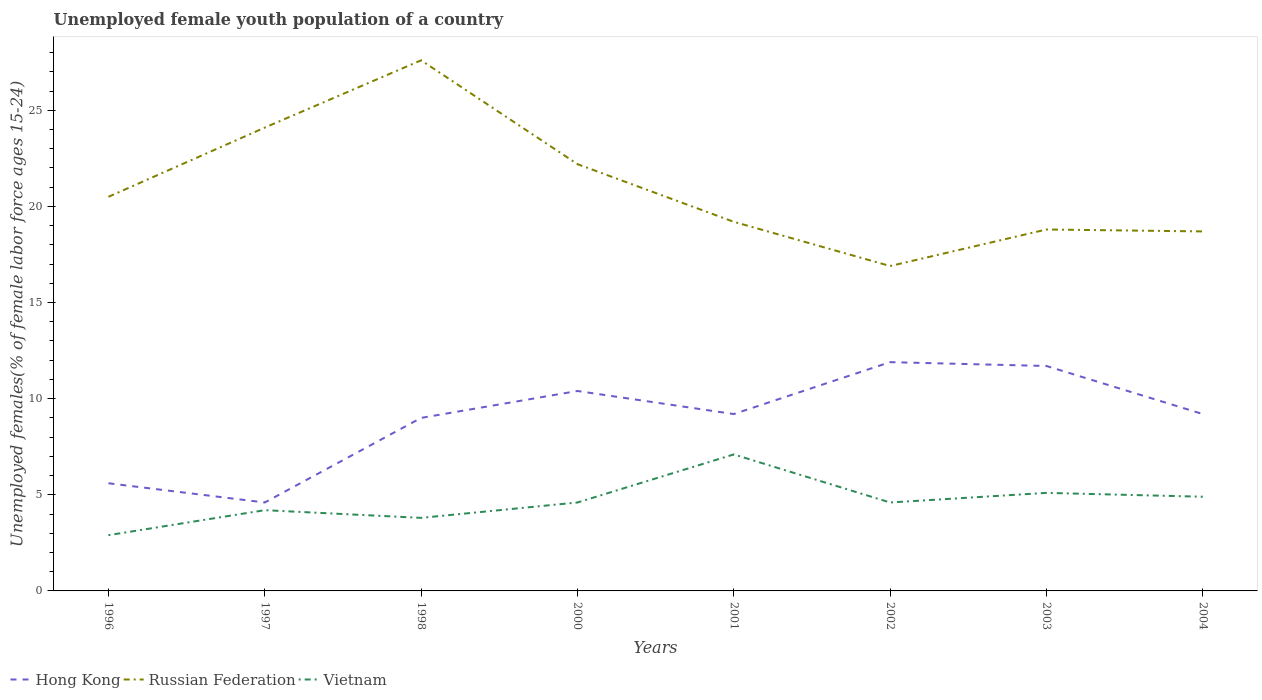How many different coloured lines are there?
Your response must be concise. 3. Across all years, what is the maximum percentage of unemployed female youth population in Vietnam?
Keep it short and to the point. 2.9. What is the total percentage of unemployed female youth population in Hong Kong in the graph?
Make the answer very short. 0. What is the difference between the highest and the second highest percentage of unemployed female youth population in Vietnam?
Provide a succinct answer. 4.2. How many lines are there?
Provide a succinct answer. 3. What is the difference between two consecutive major ticks on the Y-axis?
Offer a terse response. 5. Where does the legend appear in the graph?
Ensure brevity in your answer.  Bottom left. How many legend labels are there?
Offer a terse response. 3. How are the legend labels stacked?
Provide a short and direct response. Horizontal. What is the title of the graph?
Ensure brevity in your answer.  Unemployed female youth population of a country. What is the label or title of the Y-axis?
Offer a very short reply. Unemployed females(% of female labor force ages 15-24). What is the Unemployed females(% of female labor force ages 15-24) of Hong Kong in 1996?
Ensure brevity in your answer.  5.6. What is the Unemployed females(% of female labor force ages 15-24) in Russian Federation in 1996?
Your answer should be very brief. 20.5. What is the Unemployed females(% of female labor force ages 15-24) of Vietnam in 1996?
Offer a terse response. 2.9. What is the Unemployed females(% of female labor force ages 15-24) of Hong Kong in 1997?
Provide a short and direct response. 4.6. What is the Unemployed females(% of female labor force ages 15-24) of Russian Federation in 1997?
Your response must be concise. 24.1. What is the Unemployed females(% of female labor force ages 15-24) of Vietnam in 1997?
Make the answer very short. 4.2. What is the Unemployed females(% of female labor force ages 15-24) of Russian Federation in 1998?
Offer a very short reply. 27.6. What is the Unemployed females(% of female labor force ages 15-24) in Vietnam in 1998?
Offer a very short reply. 3.8. What is the Unemployed females(% of female labor force ages 15-24) of Hong Kong in 2000?
Keep it short and to the point. 10.4. What is the Unemployed females(% of female labor force ages 15-24) of Russian Federation in 2000?
Give a very brief answer. 22.2. What is the Unemployed females(% of female labor force ages 15-24) in Vietnam in 2000?
Ensure brevity in your answer.  4.6. What is the Unemployed females(% of female labor force ages 15-24) of Hong Kong in 2001?
Ensure brevity in your answer.  9.2. What is the Unemployed females(% of female labor force ages 15-24) of Russian Federation in 2001?
Offer a terse response. 19.2. What is the Unemployed females(% of female labor force ages 15-24) in Vietnam in 2001?
Provide a short and direct response. 7.1. What is the Unemployed females(% of female labor force ages 15-24) in Hong Kong in 2002?
Provide a short and direct response. 11.9. What is the Unemployed females(% of female labor force ages 15-24) of Russian Federation in 2002?
Offer a very short reply. 16.9. What is the Unemployed females(% of female labor force ages 15-24) in Vietnam in 2002?
Your response must be concise. 4.6. What is the Unemployed females(% of female labor force ages 15-24) in Hong Kong in 2003?
Offer a very short reply. 11.7. What is the Unemployed females(% of female labor force ages 15-24) in Russian Federation in 2003?
Offer a very short reply. 18.8. What is the Unemployed females(% of female labor force ages 15-24) in Vietnam in 2003?
Offer a terse response. 5.1. What is the Unemployed females(% of female labor force ages 15-24) of Hong Kong in 2004?
Keep it short and to the point. 9.2. What is the Unemployed females(% of female labor force ages 15-24) of Russian Federation in 2004?
Ensure brevity in your answer.  18.7. What is the Unemployed females(% of female labor force ages 15-24) in Vietnam in 2004?
Offer a terse response. 4.9. Across all years, what is the maximum Unemployed females(% of female labor force ages 15-24) of Hong Kong?
Provide a short and direct response. 11.9. Across all years, what is the maximum Unemployed females(% of female labor force ages 15-24) in Russian Federation?
Your answer should be very brief. 27.6. Across all years, what is the maximum Unemployed females(% of female labor force ages 15-24) in Vietnam?
Keep it short and to the point. 7.1. Across all years, what is the minimum Unemployed females(% of female labor force ages 15-24) of Hong Kong?
Your response must be concise. 4.6. Across all years, what is the minimum Unemployed females(% of female labor force ages 15-24) in Russian Federation?
Make the answer very short. 16.9. Across all years, what is the minimum Unemployed females(% of female labor force ages 15-24) of Vietnam?
Make the answer very short. 2.9. What is the total Unemployed females(% of female labor force ages 15-24) in Hong Kong in the graph?
Keep it short and to the point. 71.6. What is the total Unemployed females(% of female labor force ages 15-24) in Russian Federation in the graph?
Your response must be concise. 168. What is the total Unemployed females(% of female labor force ages 15-24) of Vietnam in the graph?
Ensure brevity in your answer.  37.2. What is the difference between the Unemployed females(% of female labor force ages 15-24) in Hong Kong in 1996 and that in 1997?
Provide a short and direct response. 1. What is the difference between the Unemployed females(% of female labor force ages 15-24) in Russian Federation in 1996 and that in 1997?
Give a very brief answer. -3.6. What is the difference between the Unemployed females(% of female labor force ages 15-24) in Vietnam in 1996 and that in 1997?
Make the answer very short. -1.3. What is the difference between the Unemployed females(% of female labor force ages 15-24) in Vietnam in 1996 and that in 1998?
Offer a terse response. -0.9. What is the difference between the Unemployed females(% of female labor force ages 15-24) in Russian Federation in 1996 and that in 2001?
Provide a short and direct response. 1.3. What is the difference between the Unemployed females(% of female labor force ages 15-24) in Russian Federation in 1996 and that in 2003?
Keep it short and to the point. 1.7. What is the difference between the Unemployed females(% of female labor force ages 15-24) in Vietnam in 1996 and that in 2003?
Offer a terse response. -2.2. What is the difference between the Unemployed females(% of female labor force ages 15-24) of Russian Federation in 1996 and that in 2004?
Offer a very short reply. 1.8. What is the difference between the Unemployed females(% of female labor force ages 15-24) of Vietnam in 1996 and that in 2004?
Ensure brevity in your answer.  -2. What is the difference between the Unemployed females(% of female labor force ages 15-24) in Hong Kong in 1997 and that in 1998?
Provide a succinct answer. -4.4. What is the difference between the Unemployed females(% of female labor force ages 15-24) of Russian Federation in 1997 and that in 1998?
Offer a very short reply. -3.5. What is the difference between the Unemployed females(% of female labor force ages 15-24) in Vietnam in 1997 and that in 2000?
Your answer should be very brief. -0.4. What is the difference between the Unemployed females(% of female labor force ages 15-24) in Hong Kong in 1997 and that in 2001?
Offer a very short reply. -4.6. What is the difference between the Unemployed females(% of female labor force ages 15-24) of Vietnam in 1997 and that in 2002?
Ensure brevity in your answer.  -0.4. What is the difference between the Unemployed females(% of female labor force ages 15-24) in Russian Federation in 1997 and that in 2003?
Your answer should be very brief. 5.3. What is the difference between the Unemployed females(% of female labor force ages 15-24) of Vietnam in 1997 and that in 2003?
Ensure brevity in your answer.  -0.9. What is the difference between the Unemployed females(% of female labor force ages 15-24) of Hong Kong in 1997 and that in 2004?
Give a very brief answer. -4.6. What is the difference between the Unemployed females(% of female labor force ages 15-24) in Hong Kong in 1998 and that in 2001?
Ensure brevity in your answer.  -0.2. What is the difference between the Unemployed females(% of female labor force ages 15-24) of Russian Federation in 1998 and that in 2001?
Your response must be concise. 8.4. What is the difference between the Unemployed females(% of female labor force ages 15-24) of Hong Kong in 1998 and that in 2002?
Make the answer very short. -2.9. What is the difference between the Unemployed females(% of female labor force ages 15-24) of Russian Federation in 1998 and that in 2002?
Your answer should be compact. 10.7. What is the difference between the Unemployed females(% of female labor force ages 15-24) in Hong Kong in 1998 and that in 2004?
Your answer should be very brief. -0.2. What is the difference between the Unemployed females(% of female labor force ages 15-24) of Russian Federation in 1998 and that in 2004?
Offer a very short reply. 8.9. What is the difference between the Unemployed females(% of female labor force ages 15-24) of Vietnam in 1998 and that in 2004?
Offer a very short reply. -1.1. What is the difference between the Unemployed females(% of female labor force ages 15-24) in Hong Kong in 2000 and that in 2001?
Your answer should be compact. 1.2. What is the difference between the Unemployed females(% of female labor force ages 15-24) in Russian Federation in 2000 and that in 2001?
Make the answer very short. 3. What is the difference between the Unemployed females(% of female labor force ages 15-24) in Vietnam in 2000 and that in 2001?
Offer a terse response. -2.5. What is the difference between the Unemployed females(% of female labor force ages 15-24) in Hong Kong in 2000 and that in 2002?
Keep it short and to the point. -1.5. What is the difference between the Unemployed females(% of female labor force ages 15-24) of Vietnam in 2000 and that in 2003?
Provide a short and direct response. -0.5. What is the difference between the Unemployed females(% of female labor force ages 15-24) in Russian Federation in 2000 and that in 2004?
Your answer should be very brief. 3.5. What is the difference between the Unemployed females(% of female labor force ages 15-24) of Vietnam in 2000 and that in 2004?
Your answer should be very brief. -0.3. What is the difference between the Unemployed females(% of female labor force ages 15-24) of Russian Federation in 2001 and that in 2002?
Your response must be concise. 2.3. What is the difference between the Unemployed females(% of female labor force ages 15-24) in Hong Kong in 2001 and that in 2003?
Keep it short and to the point. -2.5. What is the difference between the Unemployed females(% of female labor force ages 15-24) of Russian Federation in 2001 and that in 2003?
Provide a succinct answer. 0.4. What is the difference between the Unemployed females(% of female labor force ages 15-24) of Vietnam in 2001 and that in 2004?
Offer a terse response. 2.2. What is the difference between the Unemployed females(% of female labor force ages 15-24) in Hong Kong in 2002 and that in 2003?
Offer a very short reply. 0.2. What is the difference between the Unemployed females(% of female labor force ages 15-24) in Vietnam in 2002 and that in 2003?
Your response must be concise. -0.5. What is the difference between the Unemployed females(% of female labor force ages 15-24) in Hong Kong in 2002 and that in 2004?
Give a very brief answer. 2.7. What is the difference between the Unemployed females(% of female labor force ages 15-24) of Vietnam in 2003 and that in 2004?
Keep it short and to the point. 0.2. What is the difference between the Unemployed females(% of female labor force ages 15-24) of Hong Kong in 1996 and the Unemployed females(% of female labor force ages 15-24) of Russian Federation in 1997?
Provide a short and direct response. -18.5. What is the difference between the Unemployed females(% of female labor force ages 15-24) in Hong Kong in 1996 and the Unemployed females(% of female labor force ages 15-24) in Vietnam in 1997?
Your answer should be very brief. 1.4. What is the difference between the Unemployed females(% of female labor force ages 15-24) of Hong Kong in 1996 and the Unemployed females(% of female labor force ages 15-24) of Russian Federation in 1998?
Provide a succinct answer. -22. What is the difference between the Unemployed females(% of female labor force ages 15-24) of Hong Kong in 1996 and the Unemployed females(% of female labor force ages 15-24) of Vietnam in 1998?
Your response must be concise. 1.8. What is the difference between the Unemployed females(% of female labor force ages 15-24) in Hong Kong in 1996 and the Unemployed females(% of female labor force ages 15-24) in Russian Federation in 2000?
Provide a short and direct response. -16.6. What is the difference between the Unemployed females(% of female labor force ages 15-24) in Hong Kong in 1996 and the Unemployed females(% of female labor force ages 15-24) in Vietnam in 2000?
Your answer should be very brief. 1. What is the difference between the Unemployed females(% of female labor force ages 15-24) of Hong Kong in 1996 and the Unemployed females(% of female labor force ages 15-24) of Russian Federation in 2001?
Offer a very short reply. -13.6. What is the difference between the Unemployed females(% of female labor force ages 15-24) in Hong Kong in 1996 and the Unemployed females(% of female labor force ages 15-24) in Vietnam in 2001?
Provide a short and direct response. -1.5. What is the difference between the Unemployed females(% of female labor force ages 15-24) of Hong Kong in 1996 and the Unemployed females(% of female labor force ages 15-24) of Russian Federation in 2002?
Offer a terse response. -11.3. What is the difference between the Unemployed females(% of female labor force ages 15-24) in Hong Kong in 1996 and the Unemployed females(% of female labor force ages 15-24) in Vietnam in 2002?
Give a very brief answer. 1. What is the difference between the Unemployed females(% of female labor force ages 15-24) in Hong Kong in 1996 and the Unemployed females(% of female labor force ages 15-24) in Vietnam in 2003?
Keep it short and to the point. 0.5. What is the difference between the Unemployed females(% of female labor force ages 15-24) in Russian Federation in 1996 and the Unemployed females(% of female labor force ages 15-24) in Vietnam in 2003?
Make the answer very short. 15.4. What is the difference between the Unemployed females(% of female labor force ages 15-24) of Hong Kong in 1996 and the Unemployed females(% of female labor force ages 15-24) of Russian Federation in 2004?
Provide a succinct answer. -13.1. What is the difference between the Unemployed females(% of female labor force ages 15-24) in Russian Federation in 1996 and the Unemployed females(% of female labor force ages 15-24) in Vietnam in 2004?
Your answer should be very brief. 15.6. What is the difference between the Unemployed females(% of female labor force ages 15-24) in Russian Federation in 1997 and the Unemployed females(% of female labor force ages 15-24) in Vietnam in 1998?
Make the answer very short. 20.3. What is the difference between the Unemployed females(% of female labor force ages 15-24) in Hong Kong in 1997 and the Unemployed females(% of female labor force ages 15-24) in Russian Federation in 2000?
Make the answer very short. -17.6. What is the difference between the Unemployed females(% of female labor force ages 15-24) in Hong Kong in 1997 and the Unemployed females(% of female labor force ages 15-24) in Russian Federation in 2001?
Ensure brevity in your answer.  -14.6. What is the difference between the Unemployed females(% of female labor force ages 15-24) in Hong Kong in 1997 and the Unemployed females(% of female labor force ages 15-24) in Vietnam in 2001?
Your response must be concise. -2.5. What is the difference between the Unemployed females(% of female labor force ages 15-24) of Russian Federation in 1997 and the Unemployed females(% of female labor force ages 15-24) of Vietnam in 2001?
Offer a terse response. 17. What is the difference between the Unemployed females(% of female labor force ages 15-24) of Hong Kong in 1997 and the Unemployed females(% of female labor force ages 15-24) of Vietnam in 2002?
Make the answer very short. 0. What is the difference between the Unemployed females(% of female labor force ages 15-24) of Hong Kong in 1997 and the Unemployed females(% of female labor force ages 15-24) of Russian Federation in 2003?
Your response must be concise. -14.2. What is the difference between the Unemployed females(% of female labor force ages 15-24) of Hong Kong in 1997 and the Unemployed females(% of female labor force ages 15-24) of Russian Federation in 2004?
Give a very brief answer. -14.1. What is the difference between the Unemployed females(% of female labor force ages 15-24) in Hong Kong in 1997 and the Unemployed females(% of female labor force ages 15-24) in Vietnam in 2004?
Your answer should be compact. -0.3. What is the difference between the Unemployed females(% of female labor force ages 15-24) of Hong Kong in 1998 and the Unemployed females(% of female labor force ages 15-24) of Russian Federation in 2000?
Make the answer very short. -13.2. What is the difference between the Unemployed females(% of female labor force ages 15-24) of Hong Kong in 1998 and the Unemployed females(% of female labor force ages 15-24) of Russian Federation in 2001?
Your response must be concise. -10.2. What is the difference between the Unemployed females(% of female labor force ages 15-24) in Hong Kong in 1998 and the Unemployed females(% of female labor force ages 15-24) in Vietnam in 2001?
Offer a terse response. 1.9. What is the difference between the Unemployed females(% of female labor force ages 15-24) of Russian Federation in 1998 and the Unemployed females(% of female labor force ages 15-24) of Vietnam in 2001?
Offer a very short reply. 20.5. What is the difference between the Unemployed females(% of female labor force ages 15-24) in Hong Kong in 1998 and the Unemployed females(% of female labor force ages 15-24) in Russian Federation in 2002?
Your answer should be very brief. -7.9. What is the difference between the Unemployed females(% of female labor force ages 15-24) in Hong Kong in 1998 and the Unemployed females(% of female labor force ages 15-24) in Vietnam in 2002?
Make the answer very short. 4.4. What is the difference between the Unemployed females(% of female labor force ages 15-24) in Russian Federation in 1998 and the Unemployed females(% of female labor force ages 15-24) in Vietnam in 2004?
Offer a terse response. 22.7. What is the difference between the Unemployed females(% of female labor force ages 15-24) of Hong Kong in 2000 and the Unemployed females(% of female labor force ages 15-24) of Russian Federation in 2001?
Offer a terse response. -8.8. What is the difference between the Unemployed females(% of female labor force ages 15-24) of Hong Kong in 2000 and the Unemployed females(% of female labor force ages 15-24) of Vietnam in 2001?
Keep it short and to the point. 3.3. What is the difference between the Unemployed females(% of female labor force ages 15-24) in Russian Federation in 2000 and the Unemployed females(% of female labor force ages 15-24) in Vietnam in 2001?
Give a very brief answer. 15.1. What is the difference between the Unemployed females(% of female labor force ages 15-24) in Hong Kong in 2000 and the Unemployed females(% of female labor force ages 15-24) in Russian Federation in 2002?
Provide a short and direct response. -6.5. What is the difference between the Unemployed females(% of female labor force ages 15-24) in Russian Federation in 2000 and the Unemployed females(% of female labor force ages 15-24) in Vietnam in 2002?
Provide a short and direct response. 17.6. What is the difference between the Unemployed females(% of female labor force ages 15-24) in Russian Federation in 2000 and the Unemployed females(% of female labor force ages 15-24) in Vietnam in 2003?
Make the answer very short. 17.1. What is the difference between the Unemployed females(% of female labor force ages 15-24) of Hong Kong in 2000 and the Unemployed females(% of female labor force ages 15-24) of Russian Federation in 2004?
Offer a very short reply. -8.3. What is the difference between the Unemployed females(% of female labor force ages 15-24) in Hong Kong in 2001 and the Unemployed females(% of female labor force ages 15-24) in Vietnam in 2002?
Provide a succinct answer. 4.6. What is the difference between the Unemployed females(% of female labor force ages 15-24) in Russian Federation in 2001 and the Unemployed females(% of female labor force ages 15-24) in Vietnam in 2002?
Make the answer very short. 14.6. What is the difference between the Unemployed females(% of female labor force ages 15-24) in Hong Kong in 2001 and the Unemployed females(% of female labor force ages 15-24) in Russian Federation in 2003?
Your response must be concise. -9.6. What is the difference between the Unemployed females(% of female labor force ages 15-24) in Hong Kong in 2001 and the Unemployed females(% of female labor force ages 15-24) in Russian Federation in 2004?
Your response must be concise. -9.5. What is the difference between the Unemployed females(% of female labor force ages 15-24) of Russian Federation in 2002 and the Unemployed females(% of female labor force ages 15-24) of Vietnam in 2003?
Provide a short and direct response. 11.8. What is the difference between the Unemployed females(% of female labor force ages 15-24) in Hong Kong in 2002 and the Unemployed females(% of female labor force ages 15-24) in Russian Federation in 2004?
Your answer should be compact. -6.8. What is the difference between the Unemployed females(% of female labor force ages 15-24) in Russian Federation in 2003 and the Unemployed females(% of female labor force ages 15-24) in Vietnam in 2004?
Provide a succinct answer. 13.9. What is the average Unemployed females(% of female labor force ages 15-24) of Hong Kong per year?
Ensure brevity in your answer.  8.95. What is the average Unemployed females(% of female labor force ages 15-24) in Russian Federation per year?
Your answer should be very brief. 21. What is the average Unemployed females(% of female labor force ages 15-24) of Vietnam per year?
Your answer should be compact. 4.65. In the year 1996, what is the difference between the Unemployed females(% of female labor force ages 15-24) of Hong Kong and Unemployed females(% of female labor force ages 15-24) of Russian Federation?
Your answer should be compact. -14.9. In the year 1996, what is the difference between the Unemployed females(% of female labor force ages 15-24) of Russian Federation and Unemployed females(% of female labor force ages 15-24) of Vietnam?
Your response must be concise. 17.6. In the year 1997, what is the difference between the Unemployed females(% of female labor force ages 15-24) of Hong Kong and Unemployed females(% of female labor force ages 15-24) of Russian Federation?
Your answer should be compact. -19.5. In the year 1997, what is the difference between the Unemployed females(% of female labor force ages 15-24) of Hong Kong and Unemployed females(% of female labor force ages 15-24) of Vietnam?
Provide a succinct answer. 0.4. In the year 1998, what is the difference between the Unemployed females(% of female labor force ages 15-24) in Hong Kong and Unemployed females(% of female labor force ages 15-24) in Russian Federation?
Offer a very short reply. -18.6. In the year 1998, what is the difference between the Unemployed females(% of female labor force ages 15-24) of Hong Kong and Unemployed females(% of female labor force ages 15-24) of Vietnam?
Your answer should be compact. 5.2. In the year 1998, what is the difference between the Unemployed females(% of female labor force ages 15-24) in Russian Federation and Unemployed females(% of female labor force ages 15-24) in Vietnam?
Offer a very short reply. 23.8. In the year 2000, what is the difference between the Unemployed females(% of female labor force ages 15-24) in Russian Federation and Unemployed females(% of female labor force ages 15-24) in Vietnam?
Make the answer very short. 17.6. In the year 2002, what is the difference between the Unemployed females(% of female labor force ages 15-24) in Hong Kong and Unemployed females(% of female labor force ages 15-24) in Russian Federation?
Your answer should be very brief. -5. In the year 2002, what is the difference between the Unemployed females(% of female labor force ages 15-24) of Hong Kong and Unemployed females(% of female labor force ages 15-24) of Vietnam?
Offer a terse response. 7.3. In the year 2002, what is the difference between the Unemployed females(% of female labor force ages 15-24) of Russian Federation and Unemployed females(% of female labor force ages 15-24) of Vietnam?
Keep it short and to the point. 12.3. In the year 2003, what is the difference between the Unemployed females(% of female labor force ages 15-24) in Hong Kong and Unemployed females(% of female labor force ages 15-24) in Russian Federation?
Your response must be concise. -7.1. In the year 2003, what is the difference between the Unemployed females(% of female labor force ages 15-24) in Hong Kong and Unemployed females(% of female labor force ages 15-24) in Vietnam?
Your answer should be compact. 6.6. In the year 2004, what is the difference between the Unemployed females(% of female labor force ages 15-24) of Hong Kong and Unemployed females(% of female labor force ages 15-24) of Russian Federation?
Your answer should be compact. -9.5. In the year 2004, what is the difference between the Unemployed females(% of female labor force ages 15-24) of Russian Federation and Unemployed females(% of female labor force ages 15-24) of Vietnam?
Your response must be concise. 13.8. What is the ratio of the Unemployed females(% of female labor force ages 15-24) of Hong Kong in 1996 to that in 1997?
Offer a very short reply. 1.22. What is the ratio of the Unemployed females(% of female labor force ages 15-24) of Russian Federation in 1996 to that in 1997?
Make the answer very short. 0.85. What is the ratio of the Unemployed females(% of female labor force ages 15-24) of Vietnam in 1996 to that in 1997?
Ensure brevity in your answer.  0.69. What is the ratio of the Unemployed females(% of female labor force ages 15-24) in Hong Kong in 1996 to that in 1998?
Ensure brevity in your answer.  0.62. What is the ratio of the Unemployed females(% of female labor force ages 15-24) of Russian Federation in 1996 to that in 1998?
Provide a short and direct response. 0.74. What is the ratio of the Unemployed females(% of female labor force ages 15-24) of Vietnam in 1996 to that in 1998?
Your answer should be compact. 0.76. What is the ratio of the Unemployed females(% of female labor force ages 15-24) in Hong Kong in 1996 to that in 2000?
Make the answer very short. 0.54. What is the ratio of the Unemployed females(% of female labor force ages 15-24) of Russian Federation in 1996 to that in 2000?
Give a very brief answer. 0.92. What is the ratio of the Unemployed females(% of female labor force ages 15-24) of Vietnam in 1996 to that in 2000?
Provide a succinct answer. 0.63. What is the ratio of the Unemployed females(% of female labor force ages 15-24) of Hong Kong in 1996 to that in 2001?
Your answer should be compact. 0.61. What is the ratio of the Unemployed females(% of female labor force ages 15-24) of Russian Federation in 1996 to that in 2001?
Offer a terse response. 1.07. What is the ratio of the Unemployed females(% of female labor force ages 15-24) of Vietnam in 1996 to that in 2001?
Provide a short and direct response. 0.41. What is the ratio of the Unemployed females(% of female labor force ages 15-24) in Hong Kong in 1996 to that in 2002?
Give a very brief answer. 0.47. What is the ratio of the Unemployed females(% of female labor force ages 15-24) in Russian Federation in 1996 to that in 2002?
Provide a short and direct response. 1.21. What is the ratio of the Unemployed females(% of female labor force ages 15-24) in Vietnam in 1996 to that in 2002?
Keep it short and to the point. 0.63. What is the ratio of the Unemployed females(% of female labor force ages 15-24) in Hong Kong in 1996 to that in 2003?
Offer a very short reply. 0.48. What is the ratio of the Unemployed females(% of female labor force ages 15-24) in Russian Federation in 1996 to that in 2003?
Your answer should be very brief. 1.09. What is the ratio of the Unemployed females(% of female labor force ages 15-24) in Vietnam in 1996 to that in 2003?
Make the answer very short. 0.57. What is the ratio of the Unemployed females(% of female labor force ages 15-24) in Hong Kong in 1996 to that in 2004?
Provide a short and direct response. 0.61. What is the ratio of the Unemployed females(% of female labor force ages 15-24) in Russian Federation in 1996 to that in 2004?
Offer a terse response. 1.1. What is the ratio of the Unemployed females(% of female labor force ages 15-24) of Vietnam in 1996 to that in 2004?
Your answer should be compact. 0.59. What is the ratio of the Unemployed females(% of female labor force ages 15-24) in Hong Kong in 1997 to that in 1998?
Provide a short and direct response. 0.51. What is the ratio of the Unemployed females(% of female labor force ages 15-24) in Russian Federation in 1997 to that in 1998?
Provide a short and direct response. 0.87. What is the ratio of the Unemployed females(% of female labor force ages 15-24) of Vietnam in 1997 to that in 1998?
Your answer should be very brief. 1.11. What is the ratio of the Unemployed females(% of female labor force ages 15-24) in Hong Kong in 1997 to that in 2000?
Your response must be concise. 0.44. What is the ratio of the Unemployed females(% of female labor force ages 15-24) of Russian Federation in 1997 to that in 2000?
Your answer should be compact. 1.09. What is the ratio of the Unemployed females(% of female labor force ages 15-24) of Hong Kong in 1997 to that in 2001?
Give a very brief answer. 0.5. What is the ratio of the Unemployed females(% of female labor force ages 15-24) in Russian Federation in 1997 to that in 2001?
Provide a succinct answer. 1.26. What is the ratio of the Unemployed females(% of female labor force ages 15-24) of Vietnam in 1997 to that in 2001?
Give a very brief answer. 0.59. What is the ratio of the Unemployed females(% of female labor force ages 15-24) of Hong Kong in 1997 to that in 2002?
Keep it short and to the point. 0.39. What is the ratio of the Unemployed females(% of female labor force ages 15-24) in Russian Federation in 1997 to that in 2002?
Your response must be concise. 1.43. What is the ratio of the Unemployed females(% of female labor force ages 15-24) of Hong Kong in 1997 to that in 2003?
Ensure brevity in your answer.  0.39. What is the ratio of the Unemployed females(% of female labor force ages 15-24) in Russian Federation in 1997 to that in 2003?
Your answer should be very brief. 1.28. What is the ratio of the Unemployed females(% of female labor force ages 15-24) in Vietnam in 1997 to that in 2003?
Offer a terse response. 0.82. What is the ratio of the Unemployed females(% of female labor force ages 15-24) of Russian Federation in 1997 to that in 2004?
Make the answer very short. 1.29. What is the ratio of the Unemployed females(% of female labor force ages 15-24) of Vietnam in 1997 to that in 2004?
Your answer should be compact. 0.86. What is the ratio of the Unemployed females(% of female labor force ages 15-24) in Hong Kong in 1998 to that in 2000?
Provide a short and direct response. 0.87. What is the ratio of the Unemployed females(% of female labor force ages 15-24) in Russian Federation in 1998 to that in 2000?
Make the answer very short. 1.24. What is the ratio of the Unemployed females(% of female labor force ages 15-24) of Vietnam in 1998 to that in 2000?
Make the answer very short. 0.83. What is the ratio of the Unemployed females(% of female labor force ages 15-24) in Hong Kong in 1998 to that in 2001?
Give a very brief answer. 0.98. What is the ratio of the Unemployed females(% of female labor force ages 15-24) in Russian Federation in 1998 to that in 2001?
Provide a succinct answer. 1.44. What is the ratio of the Unemployed females(% of female labor force ages 15-24) in Vietnam in 1998 to that in 2001?
Your answer should be compact. 0.54. What is the ratio of the Unemployed females(% of female labor force ages 15-24) in Hong Kong in 1998 to that in 2002?
Offer a terse response. 0.76. What is the ratio of the Unemployed females(% of female labor force ages 15-24) of Russian Federation in 1998 to that in 2002?
Provide a succinct answer. 1.63. What is the ratio of the Unemployed females(% of female labor force ages 15-24) in Vietnam in 1998 to that in 2002?
Make the answer very short. 0.83. What is the ratio of the Unemployed females(% of female labor force ages 15-24) in Hong Kong in 1998 to that in 2003?
Offer a terse response. 0.77. What is the ratio of the Unemployed females(% of female labor force ages 15-24) of Russian Federation in 1998 to that in 2003?
Your answer should be compact. 1.47. What is the ratio of the Unemployed females(% of female labor force ages 15-24) of Vietnam in 1998 to that in 2003?
Offer a terse response. 0.75. What is the ratio of the Unemployed females(% of female labor force ages 15-24) in Hong Kong in 1998 to that in 2004?
Your answer should be compact. 0.98. What is the ratio of the Unemployed females(% of female labor force ages 15-24) in Russian Federation in 1998 to that in 2004?
Offer a terse response. 1.48. What is the ratio of the Unemployed females(% of female labor force ages 15-24) of Vietnam in 1998 to that in 2004?
Your response must be concise. 0.78. What is the ratio of the Unemployed females(% of female labor force ages 15-24) of Hong Kong in 2000 to that in 2001?
Ensure brevity in your answer.  1.13. What is the ratio of the Unemployed females(% of female labor force ages 15-24) of Russian Federation in 2000 to that in 2001?
Make the answer very short. 1.16. What is the ratio of the Unemployed females(% of female labor force ages 15-24) in Vietnam in 2000 to that in 2001?
Ensure brevity in your answer.  0.65. What is the ratio of the Unemployed females(% of female labor force ages 15-24) of Hong Kong in 2000 to that in 2002?
Your response must be concise. 0.87. What is the ratio of the Unemployed females(% of female labor force ages 15-24) of Russian Federation in 2000 to that in 2002?
Provide a succinct answer. 1.31. What is the ratio of the Unemployed females(% of female labor force ages 15-24) of Russian Federation in 2000 to that in 2003?
Provide a short and direct response. 1.18. What is the ratio of the Unemployed females(% of female labor force ages 15-24) in Vietnam in 2000 to that in 2003?
Your response must be concise. 0.9. What is the ratio of the Unemployed females(% of female labor force ages 15-24) of Hong Kong in 2000 to that in 2004?
Provide a succinct answer. 1.13. What is the ratio of the Unemployed females(% of female labor force ages 15-24) of Russian Federation in 2000 to that in 2004?
Your response must be concise. 1.19. What is the ratio of the Unemployed females(% of female labor force ages 15-24) of Vietnam in 2000 to that in 2004?
Provide a short and direct response. 0.94. What is the ratio of the Unemployed females(% of female labor force ages 15-24) of Hong Kong in 2001 to that in 2002?
Provide a succinct answer. 0.77. What is the ratio of the Unemployed females(% of female labor force ages 15-24) in Russian Federation in 2001 to that in 2002?
Provide a succinct answer. 1.14. What is the ratio of the Unemployed females(% of female labor force ages 15-24) of Vietnam in 2001 to that in 2002?
Offer a terse response. 1.54. What is the ratio of the Unemployed females(% of female labor force ages 15-24) in Hong Kong in 2001 to that in 2003?
Keep it short and to the point. 0.79. What is the ratio of the Unemployed females(% of female labor force ages 15-24) of Russian Federation in 2001 to that in 2003?
Offer a terse response. 1.02. What is the ratio of the Unemployed females(% of female labor force ages 15-24) in Vietnam in 2001 to that in 2003?
Keep it short and to the point. 1.39. What is the ratio of the Unemployed females(% of female labor force ages 15-24) of Russian Federation in 2001 to that in 2004?
Give a very brief answer. 1.03. What is the ratio of the Unemployed females(% of female labor force ages 15-24) of Vietnam in 2001 to that in 2004?
Give a very brief answer. 1.45. What is the ratio of the Unemployed females(% of female labor force ages 15-24) of Hong Kong in 2002 to that in 2003?
Keep it short and to the point. 1.02. What is the ratio of the Unemployed females(% of female labor force ages 15-24) of Russian Federation in 2002 to that in 2003?
Your response must be concise. 0.9. What is the ratio of the Unemployed females(% of female labor force ages 15-24) of Vietnam in 2002 to that in 2003?
Offer a very short reply. 0.9. What is the ratio of the Unemployed females(% of female labor force ages 15-24) in Hong Kong in 2002 to that in 2004?
Your response must be concise. 1.29. What is the ratio of the Unemployed females(% of female labor force ages 15-24) of Russian Federation in 2002 to that in 2004?
Offer a terse response. 0.9. What is the ratio of the Unemployed females(% of female labor force ages 15-24) in Vietnam in 2002 to that in 2004?
Your answer should be very brief. 0.94. What is the ratio of the Unemployed females(% of female labor force ages 15-24) of Hong Kong in 2003 to that in 2004?
Your answer should be very brief. 1.27. What is the ratio of the Unemployed females(% of female labor force ages 15-24) in Vietnam in 2003 to that in 2004?
Provide a short and direct response. 1.04. What is the difference between the highest and the second highest Unemployed females(% of female labor force ages 15-24) in Hong Kong?
Provide a succinct answer. 0.2. What is the difference between the highest and the second highest Unemployed females(% of female labor force ages 15-24) of Russian Federation?
Keep it short and to the point. 3.5. What is the difference between the highest and the lowest Unemployed females(% of female labor force ages 15-24) in Russian Federation?
Offer a very short reply. 10.7. 